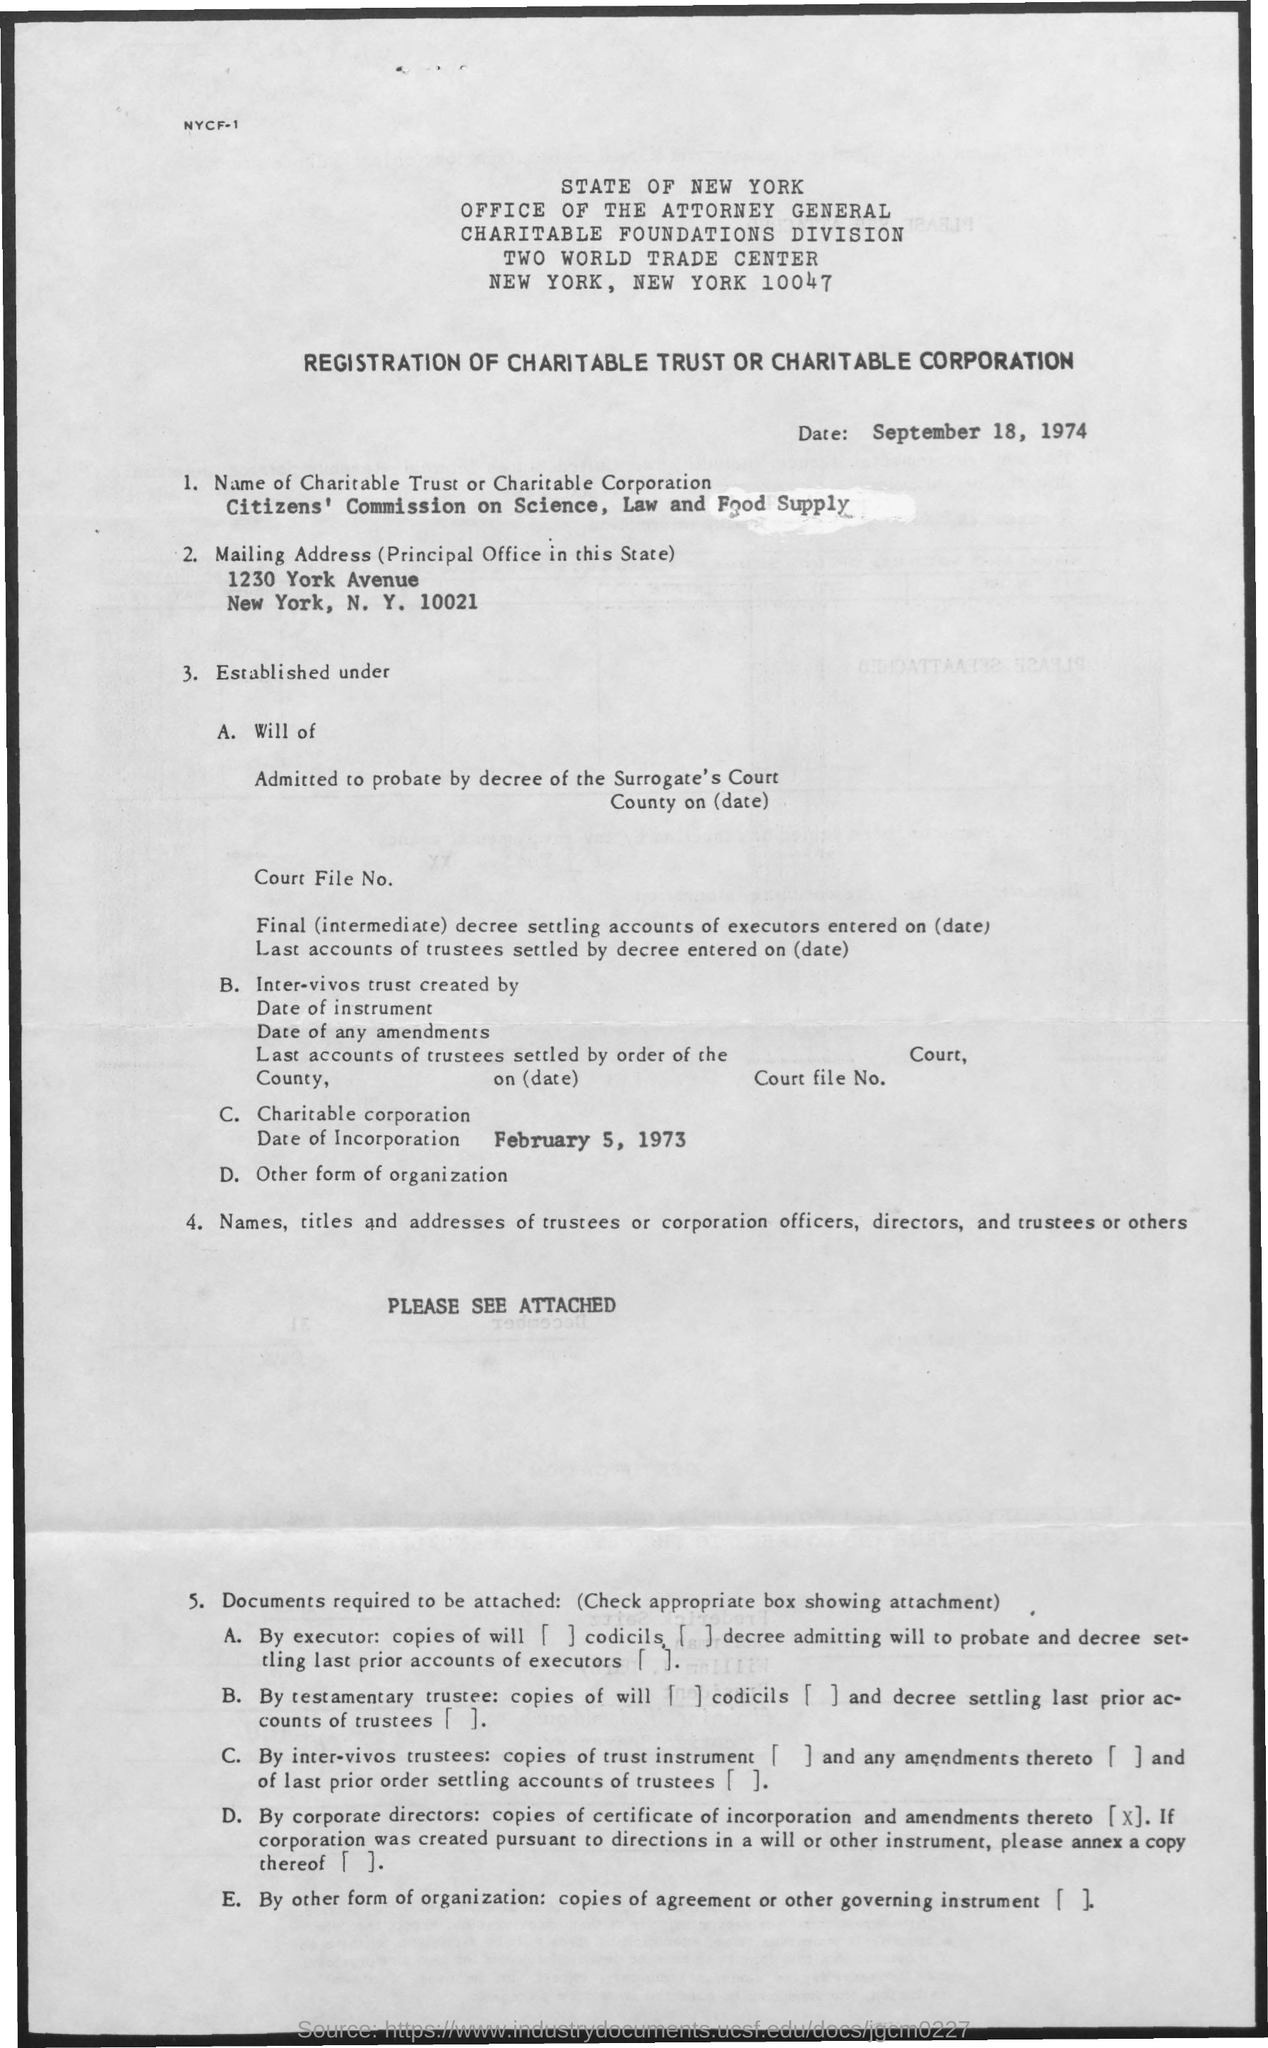What is the date of incorporation of the charitable corporation?
Keep it short and to the point. February 5, 1973. 